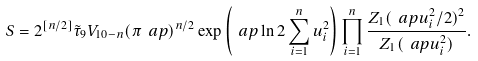Convert formula to latex. <formula><loc_0><loc_0><loc_500><loc_500>S = 2 ^ { [ n / 2 ] } \tilde { \tau } _ { 9 } V _ { 1 0 - n } ( \pi \ a p ) ^ { n / 2 } \exp \left ( \ a p \ln 2 \sum _ { i = 1 } ^ { n } u _ { i } ^ { 2 } \right ) \prod _ { i = 1 } ^ { n } \frac { Z _ { 1 } ( \ a p u _ { i } ^ { 2 } / 2 ) ^ { 2 } } { Z _ { 1 } ( \ a p u _ { i } ^ { 2 } ) } .</formula> 